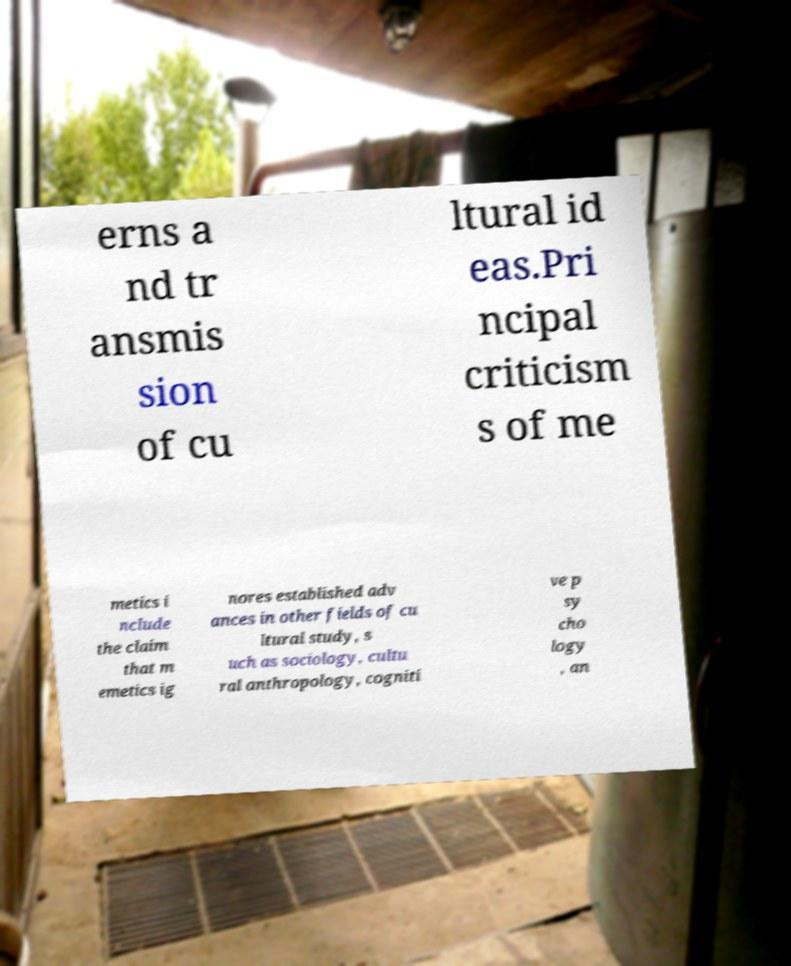What messages or text are displayed in this image? I need them in a readable, typed format. erns a nd tr ansmis sion of cu ltural id eas.Pri ncipal criticism s of me metics i nclude the claim that m emetics ig nores established adv ances in other fields of cu ltural study, s uch as sociology, cultu ral anthropology, cogniti ve p sy cho logy , an 